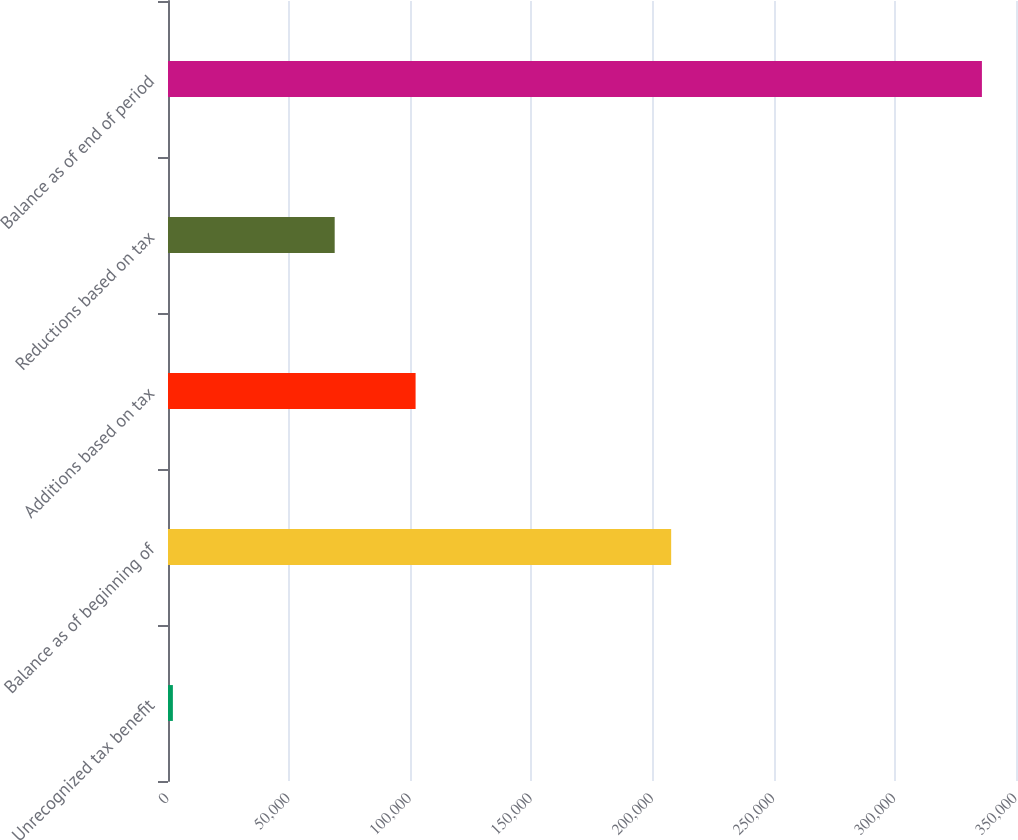Convert chart to OTSL. <chart><loc_0><loc_0><loc_500><loc_500><bar_chart><fcel>Unrecognized tax benefit<fcel>Balance as of beginning of<fcel>Additions based on tax<fcel>Reductions based on tax<fcel>Balance as of end of period<nl><fcel>2015<fcel>207675<fcel>102190<fcel>68798.6<fcel>335933<nl></chart> 